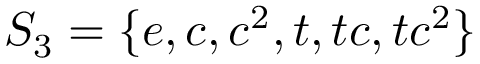<formula> <loc_0><loc_0><loc_500><loc_500>S _ { 3 } = \{ e , c , c ^ { 2 } , t , t c , t c ^ { 2 } \}</formula> 